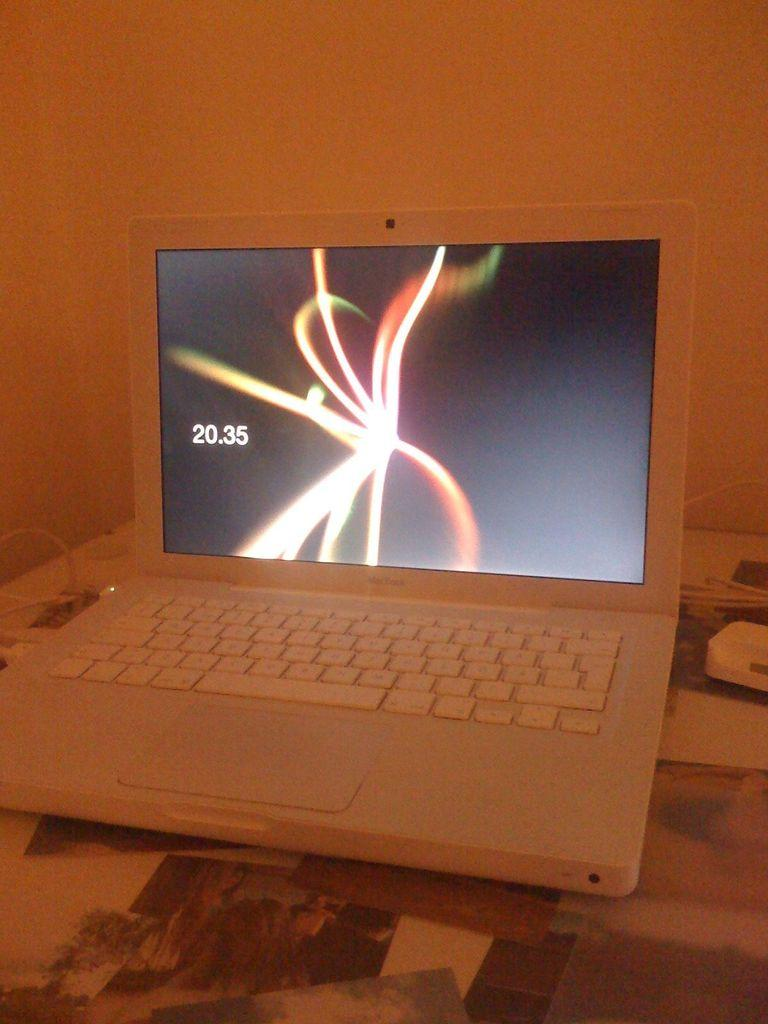<image>
Offer a succinct explanation of the picture presented. An open MacBook displays the time of 20:35. 